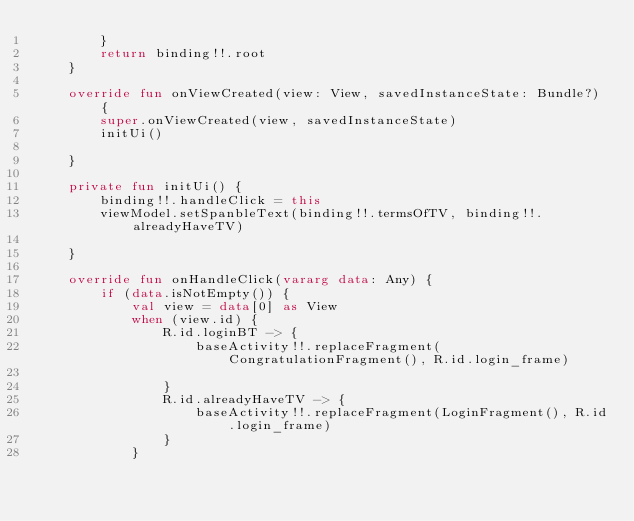Convert code to text. <code><loc_0><loc_0><loc_500><loc_500><_Kotlin_>        }
        return binding!!.root
    }

    override fun onViewCreated(view: View, savedInstanceState: Bundle?) {
        super.onViewCreated(view, savedInstanceState)
        initUi()

    }

    private fun initUi() {
        binding!!.handleClick = this
        viewModel.setSpanbleText(binding!!.termsOfTV, binding!!.alreadyHaveTV)

    }

    override fun onHandleClick(vararg data: Any) {
        if (data.isNotEmpty()) {
            val view = data[0] as View
            when (view.id) {
                R.id.loginBT -> {
                    baseActivity!!.replaceFragment(CongratulationFragment(), R.id.login_frame)

                }
                R.id.alreadyHaveTV -> {
                    baseActivity!!.replaceFragment(LoginFragment(), R.id.login_frame)
                }
            }</code> 